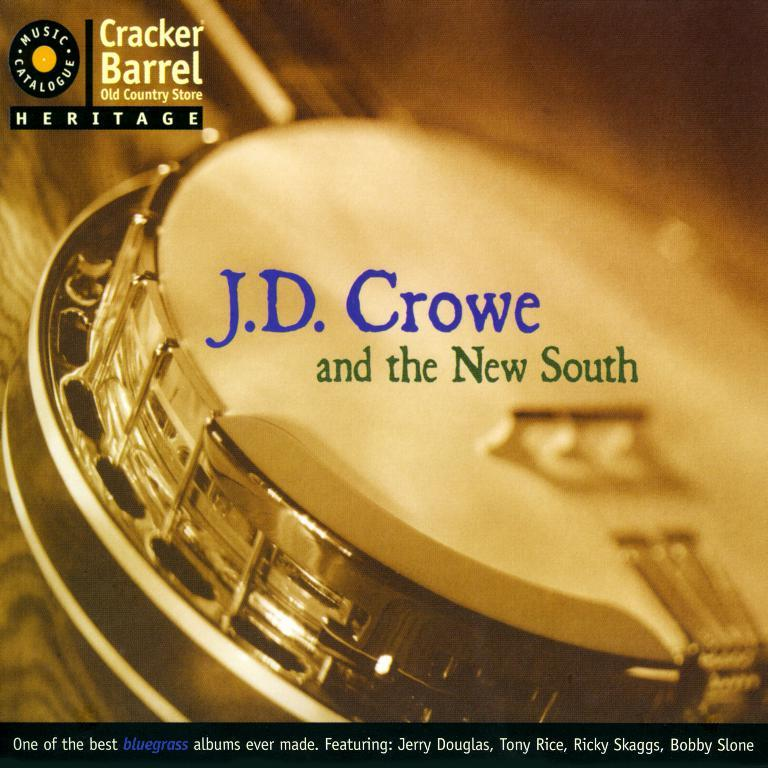<image>
Give a short and clear explanation of the subsequent image. An album by J.D. Crow and the New South is sponsored by Cracker Barrel. 